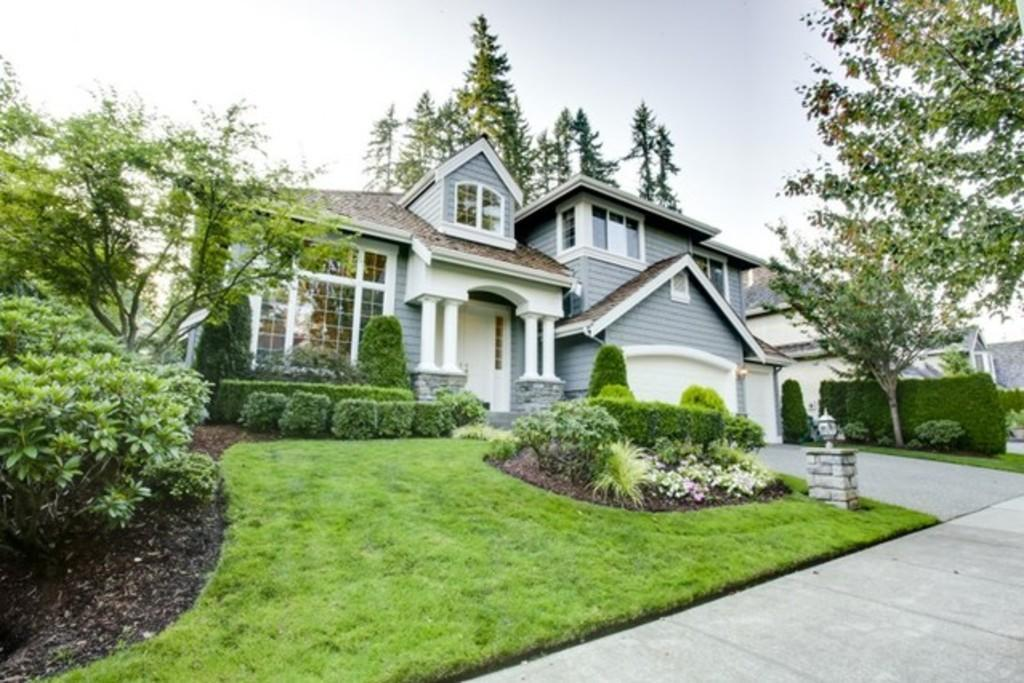What type of structures can be seen in the image? There are houses in the image. What feature do the houses have? The houses have windows. What is the path made of that people can walk on? There is a footpath in the image. What type of vegetation is present in the image? Grass, plants, and trees are visible in the image. What part of the natural environment is visible in the image? The sky is visible in the image. How many cows are grazing on the grass in the image? There are no cows present in the image; it features houses, a footpath, and various types of vegetation. What type of mark can be seen on the trees in the image? There are no marks visible on the trees in the image; only the trees themselves are present. 